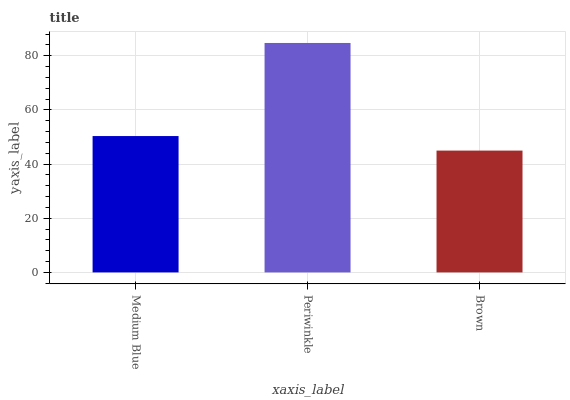Is Brown the minimum?
Answer yes or no. Yes. Is Periwinkle the maximum?
Answer yes or no. Yes. Is Periwinkle the minimum?
Answer yes or no. No. Is Brown the maximum?
Answer yes or no. No. Is Periwinkle greater than Brown?
Answer yes or no. Yes. Is Brown less than Periwinkle?
Answer yes or no. Yes. Is Brown greater than Periwinkle?
Answer yes or no. No. Is Periwinkle less than Brown?
Answer yes or no. No. Is Medium Blue the high median?
Answer yes or no. Yes. Is Medium Blue the low median?
Answer yes or no. Yes. Is Periwinkle the high median?
Answer yes or no. No. Is Brown the low median?
Answer yes or no. No. 